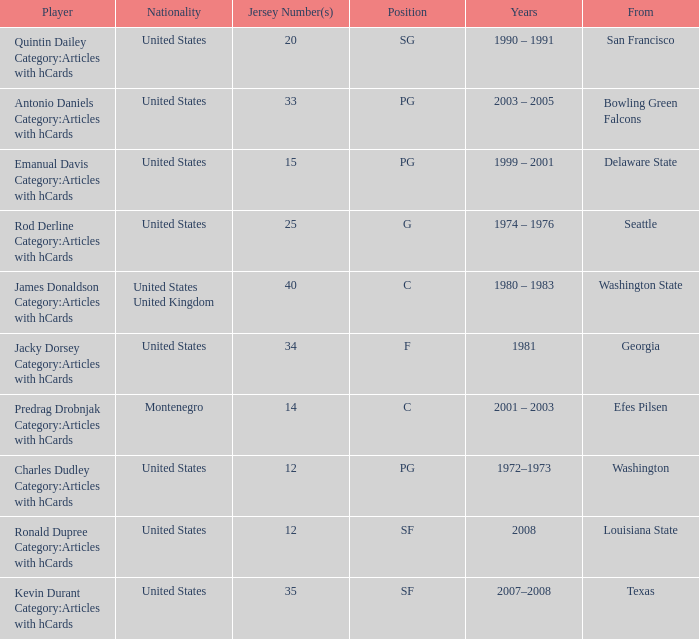Could you help me parse every detail presented in this table? {'header': ['Player', 'Nationality', 'Jersey Number(s)', 'Position', 'Years', 'From'], 'rows': [['Quintin Dailey Category:Articles with hCards', 'United States', '20', 'SG', '1990 – 1991', 'San Francisco'], ['Antonio Daniels Category:Articles with hCards', 'United States', '33', 'PG', '2003 – 2005', 'Bowling Green Falcons'], ['Emanual Davis Category:Articles with hCards', 'United States', '15', 'PG', '1999 – 2001', 'Delaware State'], ['Rod Derline Category:Articles with hCards', 'United States', '25', 'G', '1974 – 1976', 'Seattle'], ['James Donaldson Category:Articles with hCards', 'United States United Kingdom', '40', 'C', '1980 – 1983', 'Washington State'], ['Jacky Dorsey Category:Articles with hCards', 'United States', '34', 'F', '1981', 'Georgia'], ['Predrag Drobnjak Category:Articles with hCards', 'Montenegro', '14', 'C', '2001 – 2003', 'Efes Pilsen'], ['Charles Dudley Category:Articles with hCards', 'United States', '12', 'PG', '1972–1973', 'Washington'], ['Ronald Dupree Category:Articles with hCards', 'United States', '12', 'SF', '2008', 'Louisiana State'], ['Kevin Durant Category:Articles with hCards', 'United States', '35', 'SF', '2007–2008', 'Texas']]} What years featured the united states competitor with a 25 jersey number who studied at delaware state? 1999 – 2001. 